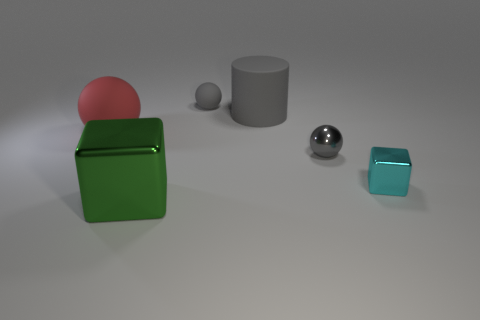There is a big rubber object that is left of the green object; is its color the same as the large metal block?
Provide a short and direct response. No. How big is the cyan object?
Your response must be concise. Small. There is a gray rubber thing on the right side of the rubber sphere that is to the right of the green shiny object; are there any tiny gray balls that are in front of it?
Provide a short and direct response. Yes. There is a big gray object; how many large matte objects are in front of it?
Offer a terse response. 1. What number of small spheres are the same color as the big shiny block?
Your answer should be very brief. 0. How many objects are blocks that are in front of the tiny block or shiny objects that are behind the small cyan metallic cube?
Your answer should be very brief. 2. Is the number of big matte objects greater than the number of large red spheres?
Keep it short and to the point. Yes. There is a matte cylinder that is behind the large red sphere; what is its color?
Keep it short and to the point. Gray. Is the shape of the large green object the same as the tiny cyan metal object?
Make the answer very short. Yes. What color is the matte thing that is right of the red rubber sphere and in front of the tiny gray matte ball?
Your response must be concise. Gray. 